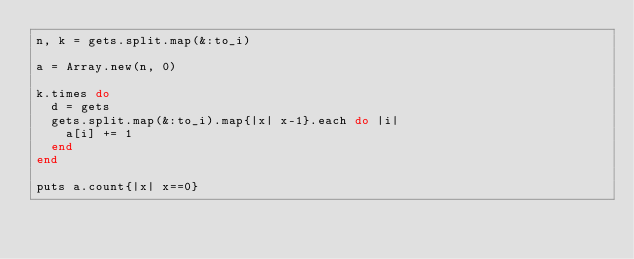Convert code to text. <code><loc_0><loc_0><loc_500><loc_500><_Ruby_>n, k = gets.split.map(&:to_i)

a = Array.new(n, 0)

k.times do
  d = gets
  gets.split.map(&:to_i).map{|x| x-1}.each do |i|
    a[i] += 1
  end
end

puts a.count{|x| x==0}
</code> 